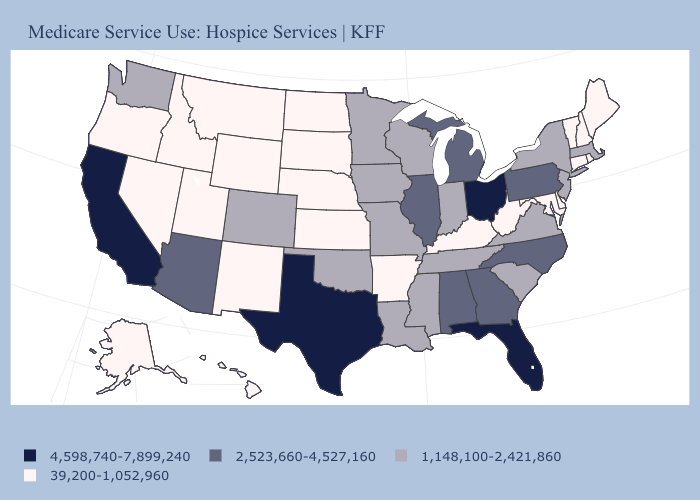Does Ohio have a higher value than Texas?
Be succinct. No. Does the map have missing data?
Be succinct. No. Name the states that have a value in the range 39,200-1,052,960?
Give a very brief answer. Alaska, Arkansas, Connecticut, Delaware, Hawaii, Idaho, Kansas, Kentucky, Maine, Maryland, Montana, Nebraska, Nevada, New Hampshire, New Mexico, North Dakota, Oregon, Rhode Island, South Dakota, Utah, Vermont, West Virginia, Wyoming. How many symbols are there in the legend?
Be succinct. 4. Name the states that have a value in the range 4,598,740-7,899,240?
Answer briefly. California, Florida, Ohio, Texas. Among the states that border Delaware , which have the highest value?
Concise answer only. Pennsylvania. Which states have the lowest value in the USA?
Be succinct. Alaska, Arkansas, Connecticut, Delaware, Hawaii, Idaho, Kansas, Kentucky, Maine, Maryland, Montana, Nebraska, Nevada, New Hampshire, New Mexico, North Dakota, Oregon, Rhode Island, South Dakota, Utah, Vermont, West Virginia, Wyoming. Does Connecticut have the highest value in the Northeast?
Be succinct. No. What is the value of Iowa?
Short answer required. 1,148,100-2,421,860. What is the value of Georgia?
Be succinct. 2,523,660-4,527,160. What is the highest value in states that border New York?
Give a very brief answer. 2,523,660-4,527,160. Among the states that border North Carolina , does Georgia have the lowest value?
Concise answer only. No. Does Iowa have the highest value in the USA?
Be succinct. No. Is the legend a continuous bar?
Keep it brief. No. Does Ohio have the highest value in the MidWest?
Answer briefly. Yes. 